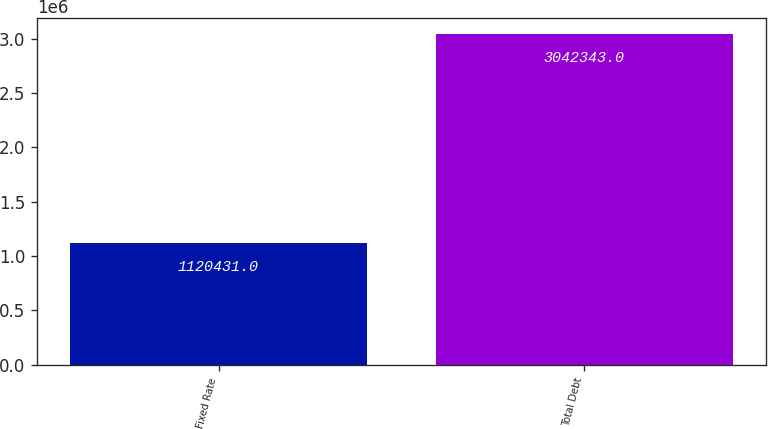Convert chart to OTSL. <chart><loc_0><loc_0><loc_500><loc_500><bar_chart><fcel>Fixed Rate<fcel>Total Debt<nl><fcel>1.12043e+06<fcel>3.04234e+06<nl></chart> 